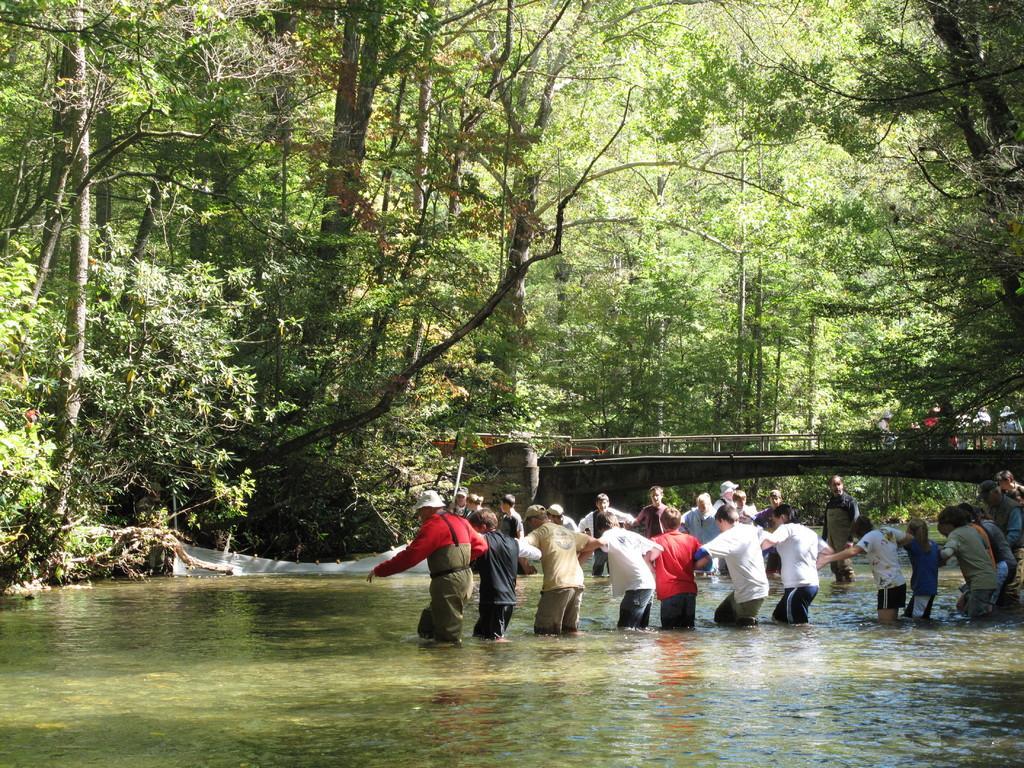How would you summarize this image in a sentence or two? Here we can see group of people standing in the water and there is a bridge. In the background we can see trees. 